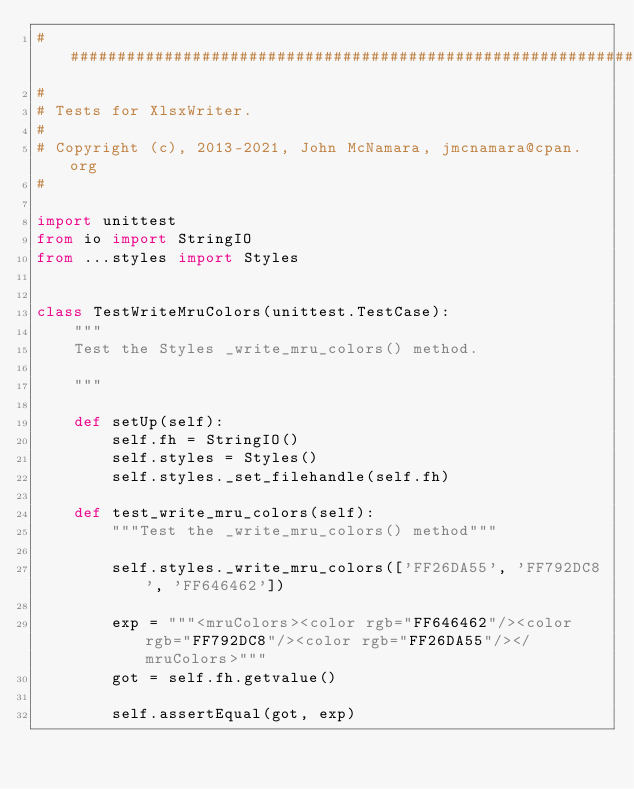Convert code to text. <code><loc_0><loc_0><loc_500><loc_500><_Python_>###############################################################################
#
# Tests for XlsxWriter.
#
# Copyright (c), 2013-2021, John McNamara, jmcnamara@cpan.org
#

import unittest
from io import StringIO
from ...styles import Styles


class TestWriteMruColors(unittest.TestCase):
    """
    Test the Styles _write_mru_colors() method.

    """

    def setUp(self):
        self.fh = StringIO()
        self.styles = Styles()
        self.styles._set_filehandle(self.fh)

    def test_write_mru_colors(self):
        """Test the _write_mru_colors() method"""

        self.styles._write_mru_colors(['FF26DA55', 'FF792DC8', 'FF646462'])

        exp = """<mruColors><color rgb="FF646462"/><color rgb="FF792DC8"/><color rgb="FF26DA55"/></mruColors>"""
        got = self.fh.getvalue()

        self.assertEqual(got, exp)
</code> 